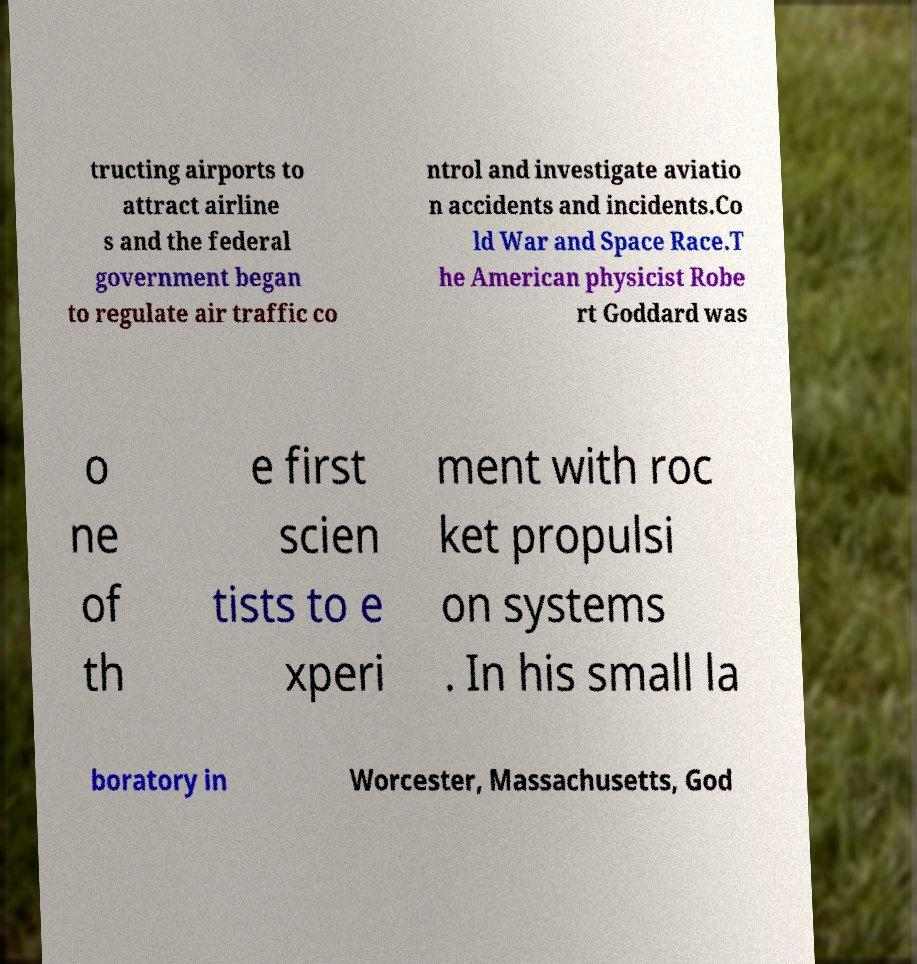What messages or text are displayed in this image? I need them in a readable, typed format. tructing airports to attract airline s and the federal government began to regulate air traffic co ntrol and investigate aviatio n accidents and incidents.Co ld War and Space Race.T he American physicist Robe rt Goddard was o ne of th e first scien tists to e xperi ment with roc ket propulsi on systems . In his small la boratory in Worcester, Massachusetts, God 